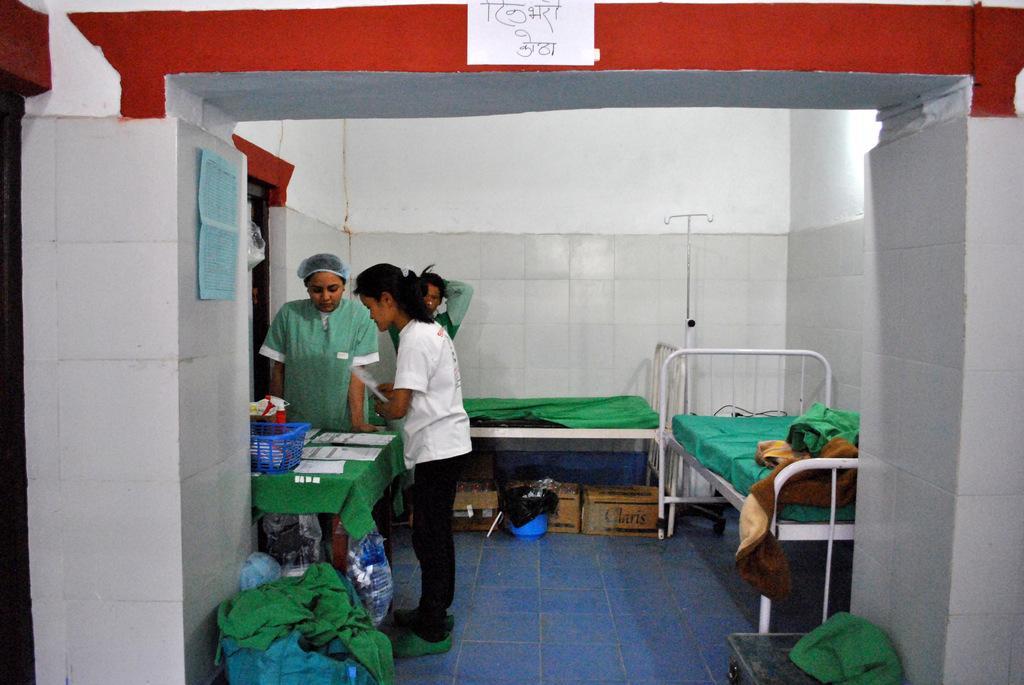Could you give a brief overview of what you see in this image? In the picture we can see a hospital room with two beds and green color beds on it and beside it we can see a table with a green color cloth on it and with some basket and some papers and medicines in it and under the bed we can see some boxes and dustbin and around the table we can see three people are standing and beside the table we can see some green color cloth on the floor, to the floor we can see files which are blue in color. 